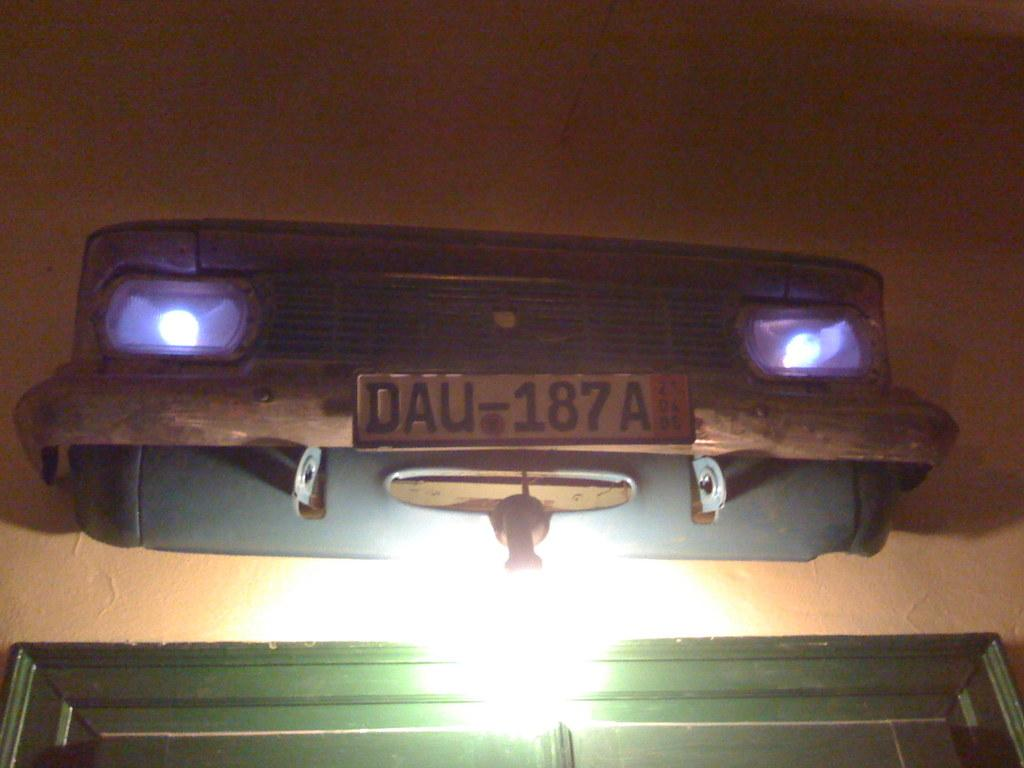What is the main subject in the center of the image? There is a fender of a car in the center of the image. What features can be seen on the car fender? There is a set of lights and a door on the car fender. Can you see a maid cleaning the car fender in the image? There is no maid present in the image. Is there a zebra grazing near the car fender in the image? There is no zebra present in the image. 